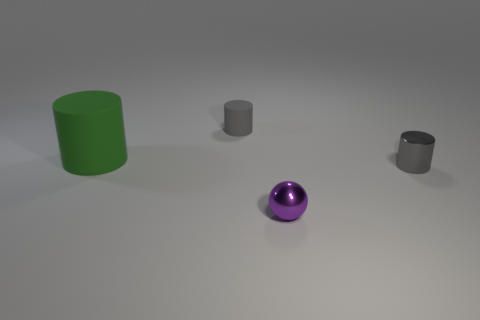Subtract all yellow balls. How many gray cylinders are left? 2 Subtract all small cylinders. How many cylinders are left? 1 Add 1 small yellow matte objects. How many objects exist? 5 Subtract all green cylinders. How many cylinders are left? 2 Subtract 1 cylinders. How many cylinders are left? 2 Subtract all yellow cylinders. Subtract all brown spheres. How many cylinders are left? 3 Subtract all cylinders. How many objects are left? 1 Add 3 purple balls. How many purple balls are left? 4 Add 1 small gray metal cylinders. How many small gray metal cylinders exist? 2 Subtract 0 blue cylinders. How many objects are left? 4 